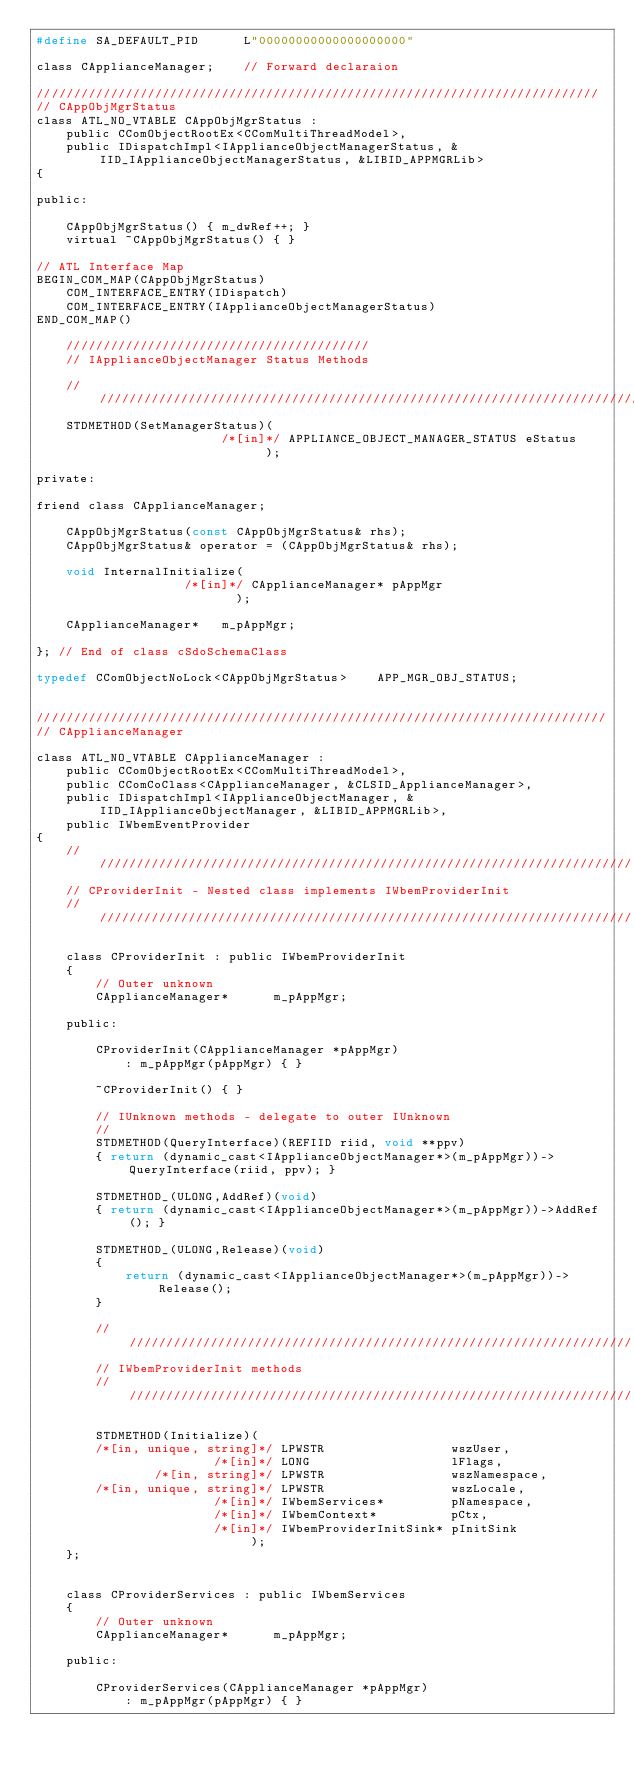Convert code to text. <code><loc_0><loc_0><loc_500><loc_500><_C_>#define SA_DEFAULT_PID      L"00000000000000000000"

class CApplianceManager;    // Forward declaraion

////////////////////////////////////////////////////////////////////////////
// CAppObjMgrStatus
class ATL_NO_VTABLE CAppObjMgrStatus : 
    public CComObjectRootEx<CComMultiThreadModel>,
    public IDispatchImpl<IApplianceObjectManagerStatus, &IID_IApplianceObjectManagerStatus, &LIBID_APPMGRLib>
{

public:

    CAppObjMgrStatus() { m_dwRef++; }
    virtual ~CAppObjMgrStatus() { }

// ATL Interface Map
BEGIN_COM_MAP(CAppObjMgrStatus)
    COM_INTERFACE_ENTRY(IDispatch)
    COM_INTERFACE_ENTRY(IApplianceObjectManagerStatus)
END_COM_MAP()

    /////////////////////////////////////////
    // IApplianceObjectManager Status Methods
    
    //////////////////////////////////////////////////////////////////////////////
    STDMETHOD(SetManagerStatus)(
                         /*[in]*/ APPLIANCE_OBJECT_MANAGER_STATUS eStatus
                               );

private:

friend class CApplianceManager;

    CAppObjMgrStatus(const CAppObjMgrStatus& rhs);
    CAppObjMgrStatus& operator = (CAppObjMgrStatus& rhs);

    void InternalInitialize(
                    /*[in]*/ CApplianceManager* pAppMgr
                           );

    CApplianceManager*   m_pAppMgr;

}; // End of class cSdoSchemaClass

typedef CComObjectNoLock<CAppObjMgrStatus>    APP_MGR_OBJ_STATUS;


/////////////////////////////////////////////////////////////////////////////
// CApplianceManager

class ATL_NO_VTABLE CApplianceManager : 
    public CComObjectRootEx<CComMultiThreadModel>,
    public CComCoClass<CApplianceManager, &CLSID_ApplianceManager>,
    public IDispatchImpl<IApplianceObjectManager, &IID_IApplianceObjectManager, &LIBID_APPMGRLib>,
    public IWbemEventProvider
{
    //////////////////////////////////////////////////////////////////////////
    // CProviderInit - Nested class implements IWbemProviderInit
    //////////////////////////////////////////////////////////////////////////

    class CProviderInit : public IWbemProviderInit
    {
        // Outer unknown
        CApplianceManager*      m_pAppMgr;

    public:

        CProviderInit(CApplianceManager *pAppMgr)
            : m_pAppMgr(pAppMgr) { }
        
        ~CProviderInit() { }

        // IUnknown methods - delegate to outer IUnknown
        //
        STDMETHOD(QueryInterface)(REFIID riid, void **ppv)
        { return (dynamic_cast<IApplianceObjectManager*>(m_pAppMgr))->QueryInterface(riid, ppv); }

        STDMETHOD_(ULONG,AddRef)(void)
        { return (dynamic_cast<IApplianceObjectManager*>(m_pAppMgr))->AddRef(); }

        STDMETHOD_(ULONG,Release)(void)
        { 
            return (dynamic_cast<IApplianceObjectManager*>(m_pAppMgr))->Release(); 
        }

        //////////////////////////////////////////////////////////////////////
        // IWbemProviderInit methods
        //////////////////////////////////////////////////////////////////////
    
        STDMETHOD(Initialize)(
        /*[in, unique, string]*/ LPWSTR                 wszUser,
                        /*[in]*/ LONG                   lFlags,
                /*[in, string]*/ LPWSTR                 wszNamespace,
        /*[in, unique, string]*/ LPWSTR                 wszLocale,
                        /*[in]*/ IWbemServices*         pNamespace,
                        /*[in]*/ IWbemContext*          pCtx,
                        /*[in]*/ IWbemProviderInitSink* pInitSink    
                             );
    };


    class CProviderServices : public IWbemServices
    {
        // Outer unknown
        CApplianceManager*      m_pAppMgr;

    public:

        CProviderServices(CApplianceManager *pAppMgr)
            : m_pAppMgr(pAppMgr) { }
        </code> 